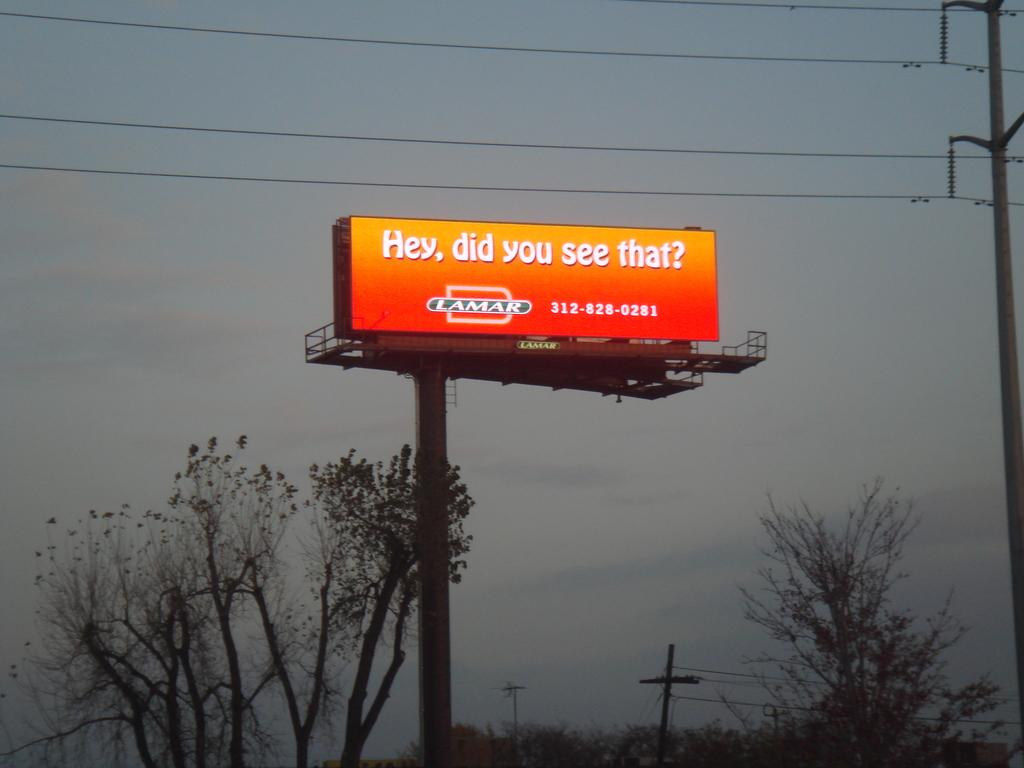<image>
Present a compact description of the photo's key features. The bright orange sign asks did you see that. 